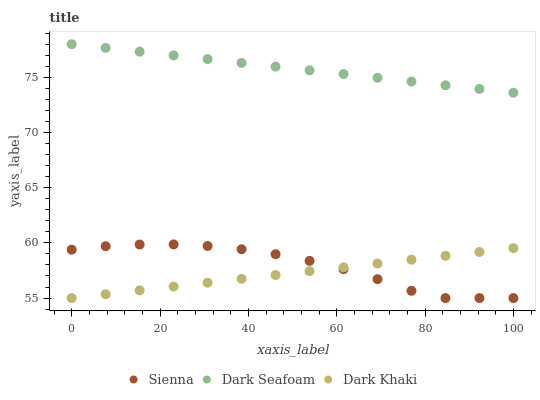Does Dark Khaki have the minimum area under the curve?
Answer yes or no. Yes. Does Dark Seafoam have the maximum area under the curve?
Answer yes or no. Yes. Does Dark Seafoam have the minimum area under the curve?
Answer yes or no. No. Does Dark Khaki have the maximum area under the curve?
Answer yes or no. No. Is Dark Khaki the smoothest?
Answer yes or no. Yes. Is Sienna the roughest?
Answer yes or no. Yes. Is Dark Seafoam the smoothest?
Answer yes or no. No. Is Dark Seafoam the roughest?
Answer yes or no. No. Does Sienna have the lowest value?
Answer yes or no. Yes. Does Dark Seafoam have the lowest value?
Answer yes or no. No. Does Dark Seafoam have the highest value?
Answer yes or no. Yes. Does Dark Khaki have the highest value?
Answer yes or no. No. Is Sienna less than Dark Seafoam?
Answer yes or no. Yes. Is Dark Seafoam greater than Dark Khaki?
Answer yes or no. Yes. Does Dark Khaki intersect Sienna?
Answer yes or no. Yes. Is Dark Khaki less than Sienna?
Answer yes or no. No. Is Dark Khaki greater than Sienna?
Answer yes or no. No. Does Sienna intersect Dark Seafoam?
Answer yes or no. No. 